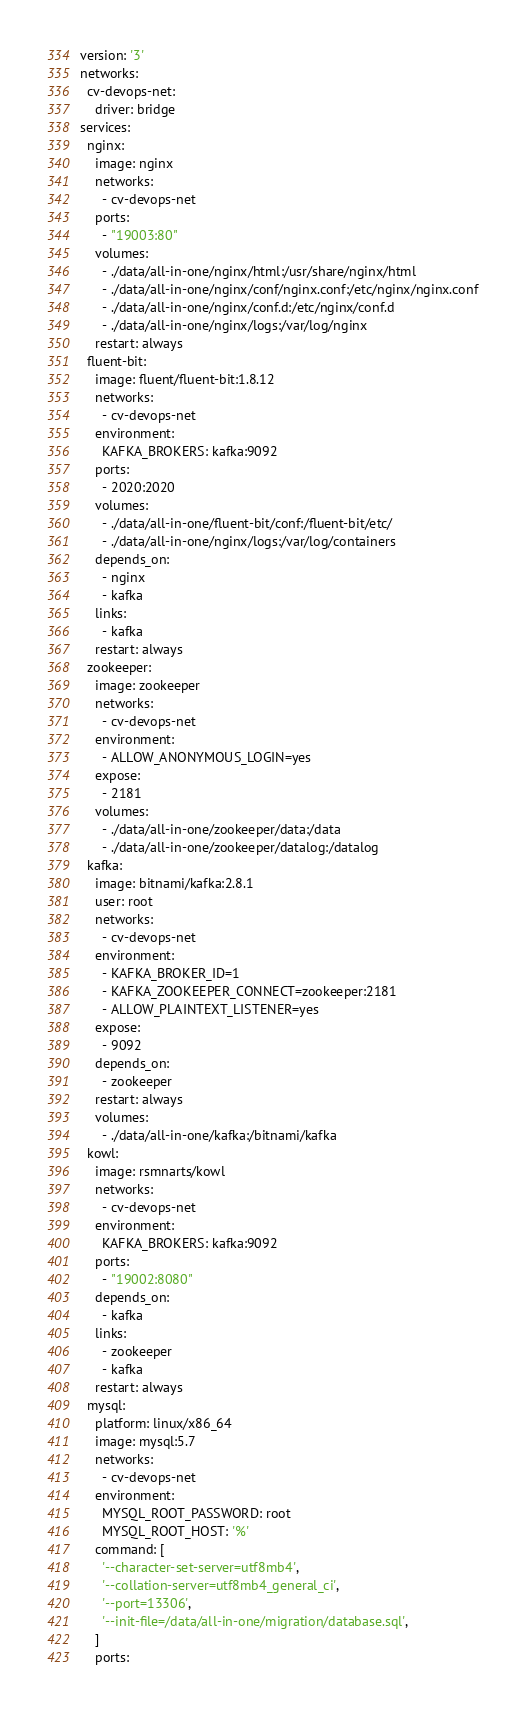<code> <loc_0><loc_0><loc_500><loc_500><_YAML_>version: '3'
networks:
  cv-devops-net:
    driver: bridge
services:
  nginx:
    image: nginx
    networks:
      - cv-devops-net
    ports:
      - "19003:80"
    volumes:
      - ./data/all-in-one/nginx/html:/usr/share/nginx/html
      - ./data/all-in-one/nginx/conf/nginx.conf:/etc/nginx/nginx.conf
      - ./data/all-in-one/nginx/conf.d:/etc/nginx/conf.d
      - ./data/all-in-one/nginx/logs:/var/log/nginx
    restart: always
  fluent-bit:
    image: fluent/fluent-bit:1.8.12
    networks:
      - cv-devops-net
    environment:
      KAFKA_BROKERS: kafka:9092
    ports:
      - 2020:2020
    volumes:
      - ./data/all-in-one/fluent-bit/conf:/fluent-bit/etc/
      - ./data/all-in-one/nginx/logs:/var/log/containers
    depends_on:
      - nginx
      - kafka
    links:
      - kafka
    restart: always
  zookeeper:
    image: zookeeper
    networks:
      - cv-devops-net
    environment:
      - ALLOW_ANONYMOUS_LOGIN=yes
    expose:
      - 2181
    volumes:
      - ./data/all-in-one/zookeeper/data:/data
      - ./data/all-in-one/zookeeper/datalog:/datalog
  kafka:
    image: bitnami/kafka:2.8.1
    user: root
    networks:
      - cv-devops-net
    environment:
      - KAFKA_BROKER_ID=1
      - KAFKA_ZOOKEEPER_CONNECT=zookeeper:2181
      - ALLOW_PLAINTEXT_LISTENER=yes
    expose:
      - 9092
    depends_on:
      - zookeeper
    restart: always
    volumes:
      - ./data/all-in-one/kafka:/bitnami/kafka
  kowl:
    image: rsmnarts/kowl
    networks:
      - cv-devops-net
    environment:
      KAFKA_BROKERS: kafka:9092
    ports:
      - "19002:8080"
    depends_on:
      - kafka
    links:
      - zookeeper
      - kafka
    restart: always
  mysql:
    platform: linux/x86_64
    image: mysql:5.7
    networks:
      - cv-devops-net
    environment:
      MYSQL_ROOT_PASSWORD: root
      MYSQL_ROOT_HOST: '%'
    command: [
      '--character-set-server=utf8mb4',
      '--collation-server=utf8mb4_general_ci',
      '--port=13306',
      '--init-file=/data/all-in-one/migration/database.sql',
    ]
    ports:</code> 